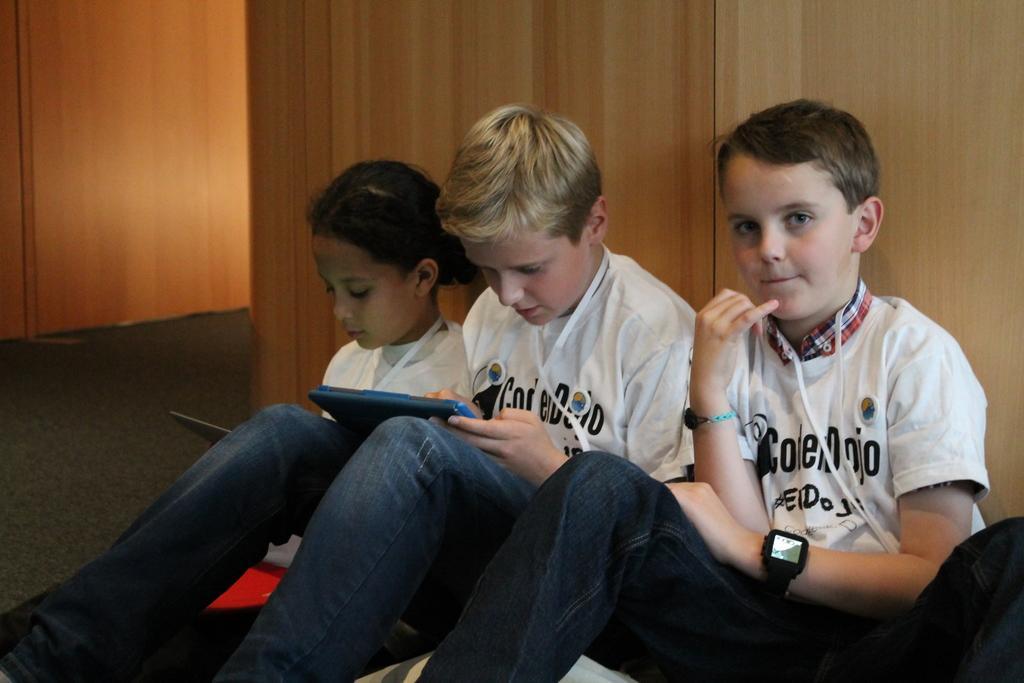Can you describe this image briefly? In this image, we can see kids wearing clothes and sitting in front of the wooden wall. There is a kid in the middle of the image, holding an object with his hand. 